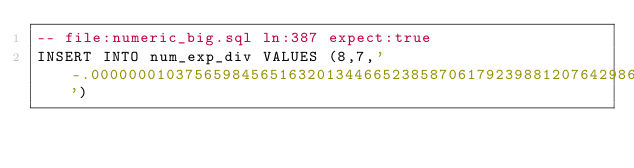<code> <loc_0><loc_0><loc_500><loc_500><_SQL_>-- file:numeric_big.sql ln:387 expect:true
INSERT INTO num_exp_div VALUES (8,7,'-.000000010375659845651632013446652385870617923988120764298690164486716047614260682259722116360931978511176121353975789418625836899338225571166376573732227571704071000348895791547943896682585450808398324252224265156214259224488248639550967292466343168350213394398101712526534464002532408445204630441167137710565437434313424987517531891145368203998329086865151248833625645567863740298397742783405267970015165358620026813812552194344790169289440822038223606218360105618852154152168496637886434061050281055613760360200323363465925493033734895631921307644481639236601187225135325401868178006133838932915485272554505684060229409404902185944047523033315868230944723282246159741659387362889777495094736963530708159604929268812778894177095572578862150793098548829744006499229853198046828954650334595737117597239208825268')
</code> 